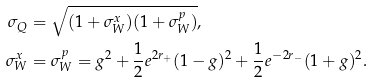<formula> <loc_0><loc_0><loc_500><loc_500>\sigma _ { Q } & = \sqrt { ( 1 + \sigma _ { W } ^ { x } ) ( 1 + \sigma _ { W } ^ { p } ) } , \\ \sigma _ { W } ^ { x } & = \sigma _ { W } ^ { p } = g ^ { 2 } + \frac { 1 } { 2 } e ^ { 2 r _ { + } } ( 1 - g ) ^ { 2 } + \frac { 1 } { 2 } e ^ { - 2 r _ { - } } ( 1 + g ) ^ { 2 } .</formula> 